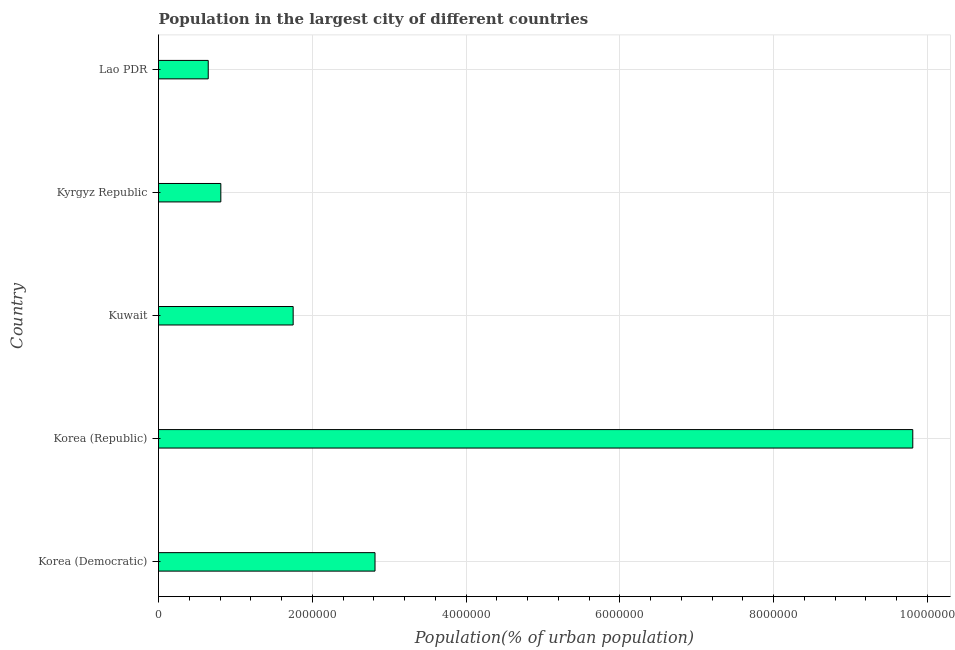Does the graph contain any zero values?
Your answer should be very brief. No. Does the graph contain grids?
Your response must be concise. Yes. What is the title of the graph?
Provide a succinct answer. Population in the largest city of different countries. What is the label or title of the X-axis?
Provide a short and direct response. Population(% of urban population). What is the population in largest city in Kyrgyz Republic?
Give a very brief answer. 8.11e+05. Across all countries, what is the maximum population in largest city?
Keep it short and to the point. 9.81e+06. Across all countries, what is the minimum population in largest city?
Offer a terse response. 6.47e+05. In which country was the population in largest city maximum?
Offer a very short reply. Korea (Republic). In which country was the population in largest city minimum?
Provide a short and direct response. Lao PDR. What is the sum of the population in largest city?
Keep it short and to the point. 1.58e+07. What is the difference between the population in largest city in Korea (Democratic) and Kyrgyz Republic?
Your answer should be very brief. 2.01e+06. What is the average population in largest city per country?
Keep it short and to the point. 3.17e+06. What is the median population in largest city?
Make the answer very short. 1.75e+06. What is the ratio of the population in largest city in Korea (Democratic) to that in Kyrgyz Republic?
Ensure brevity in your answer.  3.47. Is the population in largest city in Korea (Democratic) less than that in Kuwait?
Provide a succinct answer. No. What is the difference between the highest and the second highest population in largest city?
Your response must be concise. 7.00e+06. What is the difference between the highest and the lowest population in largest city?
Your response must be concise. 9.16e+06. In how many countries, is the population in largest city greater than the average population in largest city taken over all countries?
Ensure brevity in your answer.  1. How many bars are there?
Offer a very short reply. 5. How many countries are there in the graph?
Provide a succinct answer. 5. What is the Population(% of urban population) in Korea (Democratic)?
Offer a very short reply. 2.82e+06. What is the Population(% of urban population) in Korea (Republic)?
Your answer should be compact. 9.81e+06. What is the Population(% of urban population) in Kuwait?
Offer a very short reply. 1.75e+06. What is the Population(% of urban population) of Kyrgyz Republic?
Your answer should be compact. 8.11e+05. What is the Population(% of urban population) of Lao PDR?
Keep it short and to the point. 6.47e+05. What is the difference between the Population(% of urban population) in Korea (Democratic) and Korea (Republic)?
Give a very brief answer. -7.00e+06. What is the difference between the Population(% of urban population) in Korea (Democratic) and Kuwait?
Offer a terse response. 1.06e+06. What is the difference between the Population(% of urban population) in Korea (Democratic) and Kyrgyz Republic?
Keep it short and to the point. 2.01e+06. What is the difference between the Population(% of urban population) in Korea (Democratic) and Lao PDR?
Keep it short and to the point. 2.17e+06. What is the difference between the Population(% of urban population) in Korea (Republic) and Kuwait?
Offer a very short reply. 8.06e+06. What is the difference between the Population(% of urban population) in Korea (Republic) and Kyrgyz Republic?
Your answer should be compact. 9.00e+06. What is the difference between the Population(% of urban population) in Korea (Republic) and Lao PDR?
Provide a succinct answer. 9.16e+06. What is the difference between the Population(% of urban population) in Kuwait and Kyrgyz Republic?
Keep it short and to the point. 9.41e+05. What is the difference between the Population(% of urban population) in Kuwait and Lao PDR?
Ensure brevity in your answer.  1.10e+06. What is the difference between the Population(% of urban population) in Kyrgyz Republic and Lao PDR?
Give a very brief answer. 1.64e+05. What is the ratio of the Population(% of urban population) in Korea (Democratic) to that in Korea (Republic)?
Your response must be concise. 0.29. What is the ratio of the Population(% of urban population) in Korea (Democratic) to that in Kuwait?
Offer a very short reply. 1.61. What is the ratio of the Population(% of urban population) in Korea (Democratic) to that in Kyrgyz Republic?
Make the answer very short. 3.47. What is the ratio of the Population(% of urban population) in Korea (Democratic) to that in Lao PDR?
Offer a terse response. 4.36. What is the ratio of the Population(% of urban population) in Korea (Republic) to that in Kuwait?
Your answer should be compact. 5.6. What is the ratio of the Population(% of urban population) in Korea (Republic) to that in Kyrgyz Republic?
Provide a succinct answer. 12.1. What is the ratio of the Population(% of urban population) in Korea (Republic) to that in Lao PDR?
Ensure brevity in your answer.  15.17. What is the ratio of the Population(% of urban population) in Kuwait to that in Kyrgyz Republic?
Your response must be concise. 2.16. What is the ratio of the Population(% of urban population) in Kuwait to that in Lao PDR?
Provide a short and direct response. 2.71. What is the ratio of the Population(% of urban population) in Kyrgyz Republic to that in Lao PDR?
Your response must be concise. 1.25. 